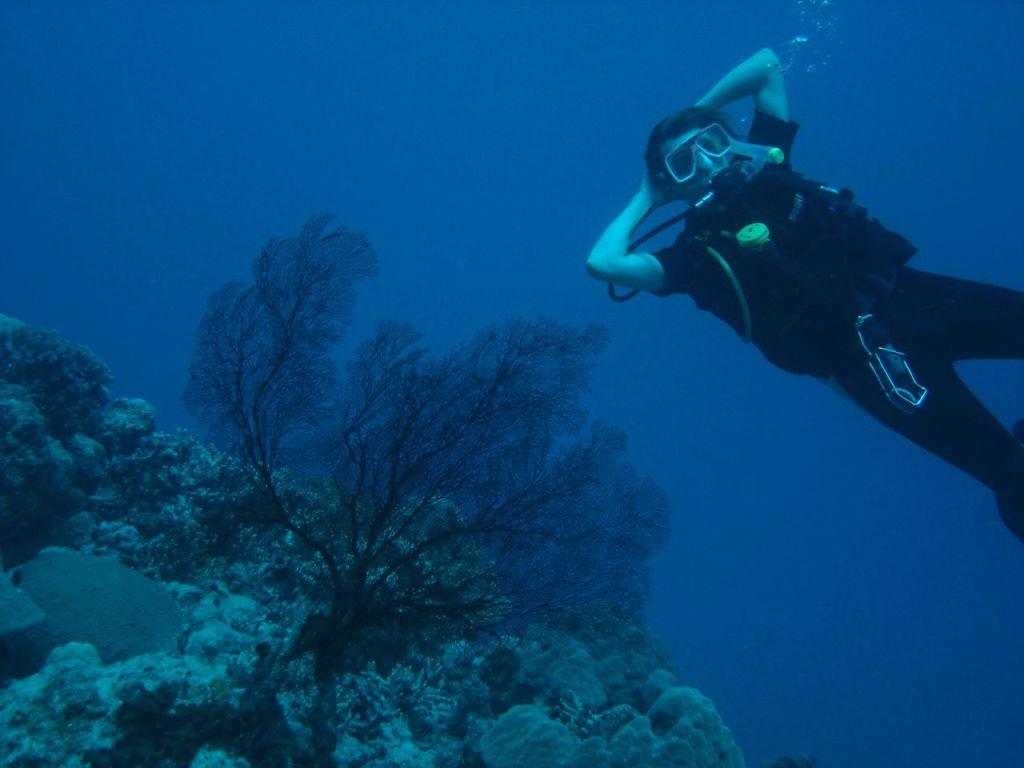Where was the image taken? The image was taken in the sea. What can be found inside the sea in the image? There are weeds inside the sea in the image. What activity is the person in the image engaged in? The person in the top right corner of the image is diving. What type of comfort can be seen in the image? There is no reference to comfort in the image, as it features a person diving in the sea with weeds. 